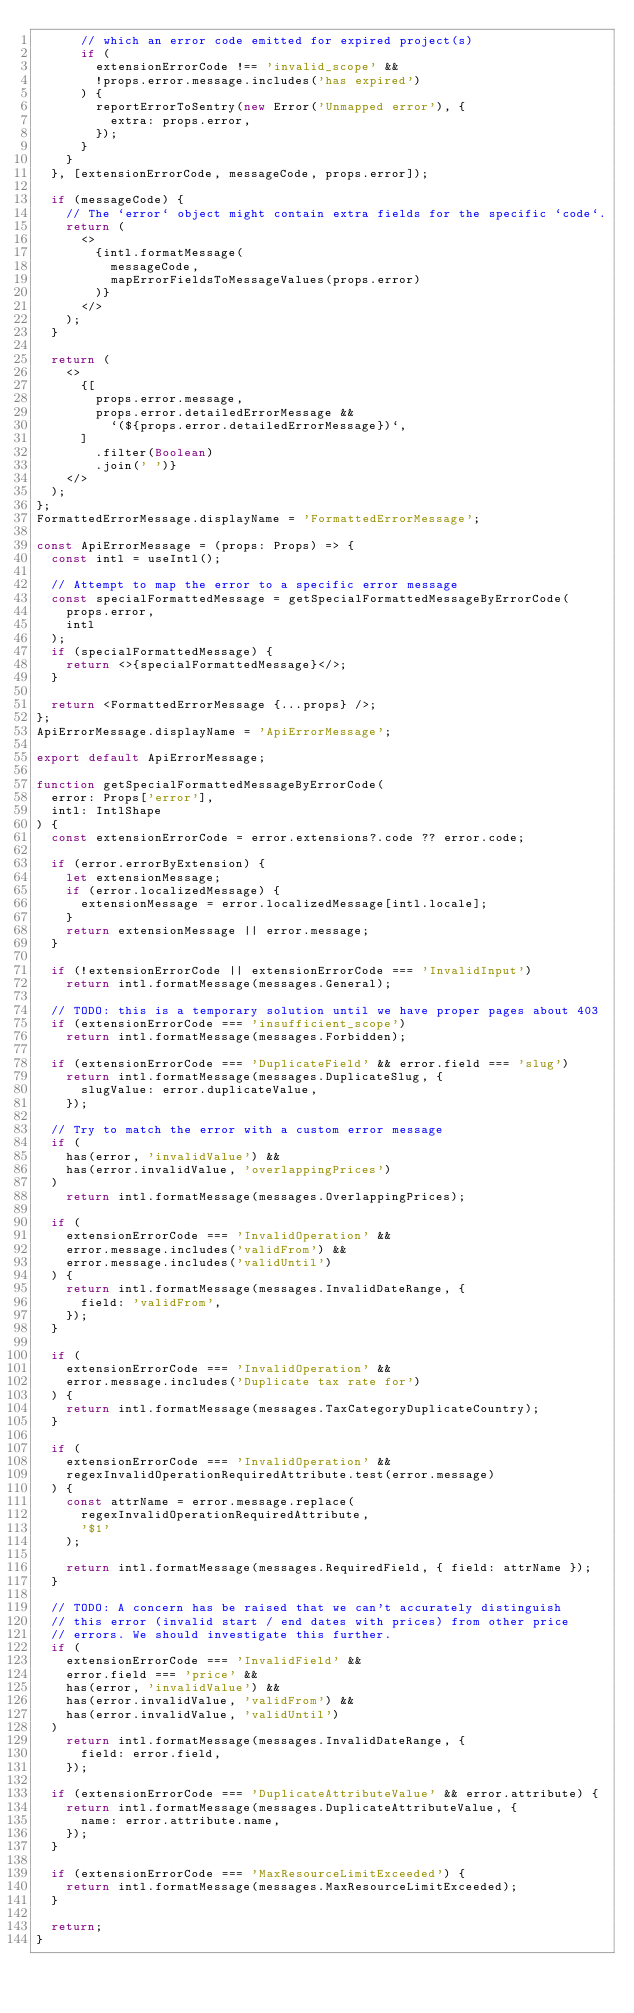<code> <loc_0><loc_0><loc_500><loc_500><_TypeScript_>      // which an error code emitted for expired project(s)
      if (
        extensionErrorCode !== 'invalid_scope' &&
        !props.error.message.includes('has expired')
      ) {
        reportErrorToSentry(new Error('Unmapped error'), {
          extra: props.error,
        });
      }
    }
  }, [extensionErrorCode, messageCode, props.error]);

  if (messageCode) {
    // The `error` object might contain extra fields for the specific `code`.
    return (
      <>
        {intl.formatMessage(
          messageCode,
          mapErrorFieldsToMessageValues(props.error)
        )}
      </>
    );
  }

  return (
    <>
      {[
        props.error.message,
        props.error.detailedErrorMessage &&
          `(${props.error.detailedErrorMessage})`,
      ]
        .filter(Boolean)
        .join(' ')}
    </>
  );
};
FormattedErrorMessage.displayName = 'FormattedErrorMessage';

const ApiErrorMessage = (props: Props) => {
  const intl = useIntl();

  // Attempt to map the error to a specific error message
  const specialFormattedMessage = getSpecialFormattedMessageByErrorCode(
    props.error,
    intl
  );
  if (specialFormattedMessage) {
    return <>{specialFormattedMessage}</>;
  }

  return <FormattedErrorMessage {...props} />;
};
ApiErrorMessage.displayName = 'ApiErrorMessage';

export default ApiErrorMessage;

function getSpecialFormattedMessageByErrorCode(
  error: Props['error'],
  intl: IntlShape
) {
  const extensionErrorCode = error.extensions?.code ?? error.code;

  if (error.errorByExtension) {
    let extensionMessage;
    if (error.localizedMessage) {
      extensionMessage = error.localizedMessage[intl.locale];
    }
    return extensionMessage || error.message;
  }

  if (!extensionErrorCode || extensionErrorCode === 'InvalidInput')
    return intl.formatMessage(messages.General);

  // TODO: this is a temporary solution until we have proper pages about 403
  if (extensionErrorCode === 'insufficient_scope')
    return intl.formatMessage(messages.Forbidden);

  if (extensionErrorCode === 'DuplicateField' && error.field === 'slug')
    return intl.formatMessage(messages.DuplicateSlug, {
      slugValue: error.duplicateValue,
    });

  // Try to match the error with a custom error message
  if (
    has(error, 'invalidValue') &&
    has(error.invalidValue, 'overlappingPrices')
  )
    return intl.formatMessage(messages.OverlappingPrices);

  if (
    extensionErrorCode === 'InvalidOperation' &&
    error.message.includes('validFrom') &&
    error.message.includes('validUntil')
  ) {
    return intl.formatMessage(messages.InvalidDateRange, {
      field: 'validFrom',
    });
  }

  if (
    extensionErrorCode === 'InvalidOperation' &&
    error.message.includes('Duplicate tax rate for')
  ) {
    return intl.formatMessage(messages.TaxCategoryDuplicateCountry);
  }

  if (
    extensionErrorCode === 'InvalidOperation' &&
    regexInvalidOperationRequiredAttribute.test(error.message)
  ) {
    const attrName = error.message.replace(
      regexInvalidOperationRequiredAttribute,
      '$1'
    );

    return intl.formatMessage(messages.RequiredField, { field: attrName });
  }

  // TODO: A concern has be raised that we can't accurately distinguish
  // this error (invalid start / end dates with prices) from other price
  // errors. We should investigate this further.
  if (
    extensionErrorCode === 'InvalidField' &&
    error.field === 'price' &&
    has(error, 'invalidValue') &&
    has(error.invalidValue, 'validFrom') &&
    has(error.invalidValue, 'validUntil')
  )
    return intl.formatMessage(messages.InvalidDateRange, {
      field: error.field,
    });

  if (extensionErrorCode === 'DuplicateAttributeValue' && error.attribute) {
    return intl.formatMessage(messages.DuplicateAttributeValue, {
      name: error.attribute.name,
    });
  }

  if (extensionErrorCode === 'MaxResourceLimitExceeded') {
    return intl.formatMessage(messages.MaxResourceLimitExceeded);
  }

  return;
}
</code> 